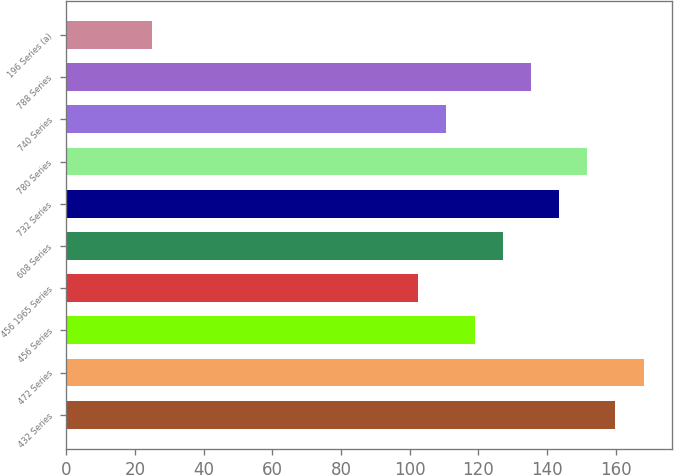<chart> <loc_0><loc_0><loc_500><loc_500><bar_chart><fcel>432 Series<fcel>472 Series<fcel>456 Series<fcel>456 1965 Series<fcel>608 Series<fcel>732 Series<fcel>780 Series<fcel>740 Series<fcel>788 Series<fcel>196 Series (a)<nl><fcel>159.9<fcel>168.1<fcel>118.9<fcel>102.5<fcel>127.1<fcel>143.5<fcel>151.7<fcel>110.7<fcel>135.3<fcel>25<nl></chart> 